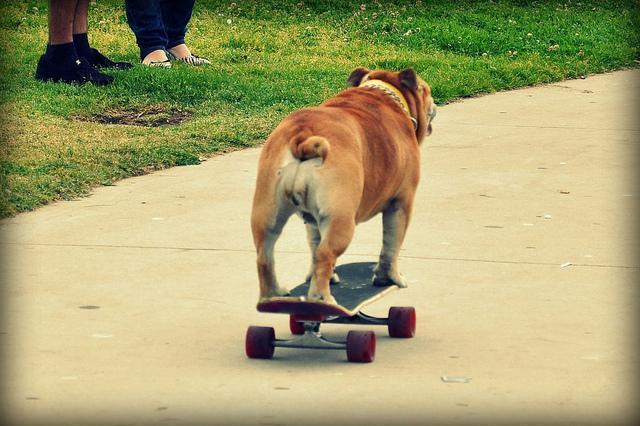How many people can you see?
Give a very brief answer. 2. 